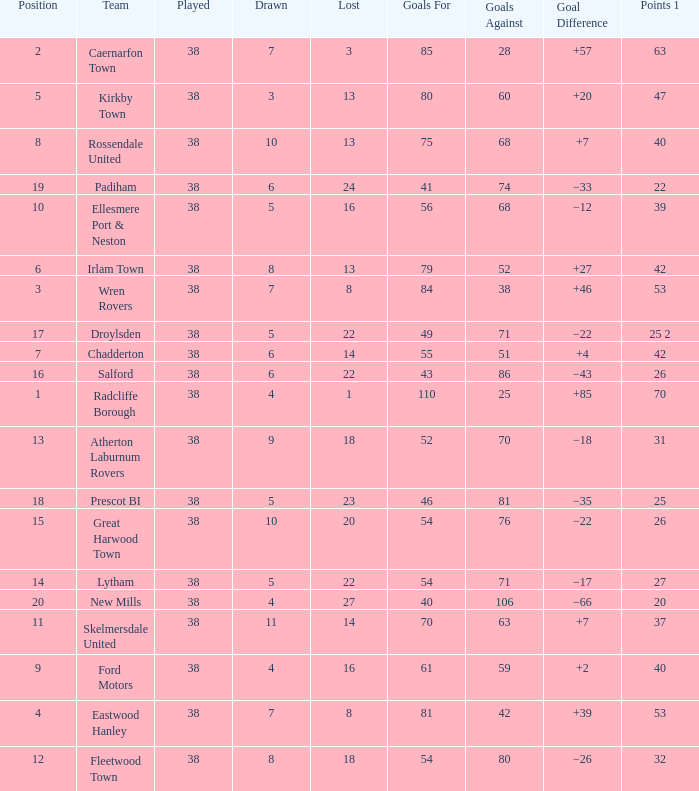How much Drawn has Goals Against larger than 74, and a Lost smaller than 20, and a Played larger than 38? 0.0. 